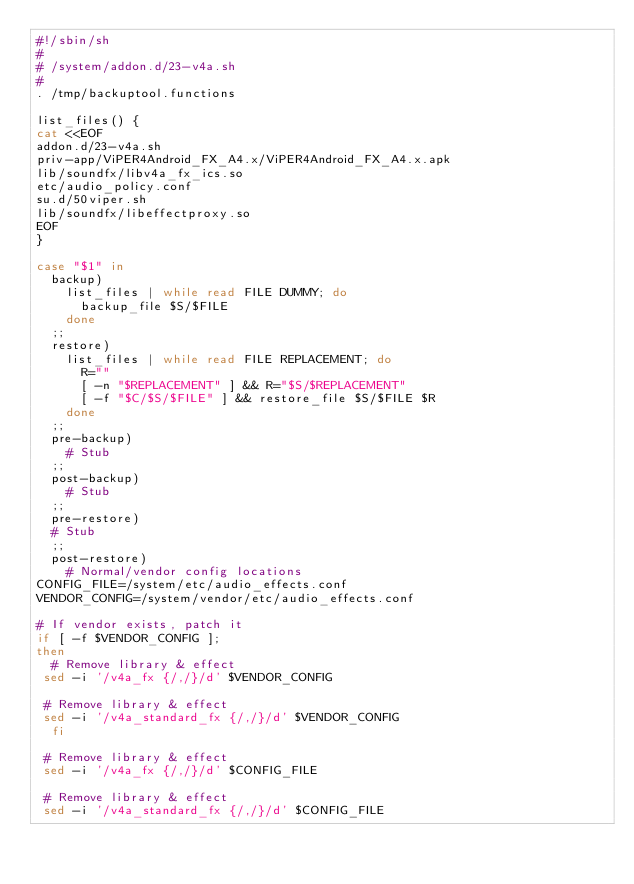<code> <loc_0><loc_0><loc_500><loc_500><_Bash_>#!/sbin/sh
# 
# /system/addon.d/23-v4a.sh
#
. /tmp/backuptool.functions

list_files() {
cat <<EOF
addon.d/23-v4a.sh
priv-app/ViPER4Android_FX_A4.x/ViPER4Android_FX_A4.x.apk
lib/soundfx/libv4a_fx_ics.so
etc/audio_policy.conf
su.d/50viper.sh
lib/soundfx/libeffectproxy.so
EOF
}

case "$1" in
  backup)
    list_files | while read FILE DUMMY; do
      backup_file $S/$FILE
    done
  ;;
  restore)
    list_files | while read FILE REPLACEMENT; do
      R=""
      [ -n "$REPLACEMENT" ] && R="$S/$REPLACEMENT"
      [ -f "$C/$S/$FILE" ] && restore_file $S/$FILE $R
    done
  ;;
  pre-backup)
    # Stub
  ;;
  post-backup)
    # Stub
  ;;
  pre-restore)
	# Stub
  ;;
  post-restore)
    # Normal/vendor config locations
CONFIG_FILE=/system/etc/audio_effects.conf
VENDOR_CONFIG=/system/vendor/etc/audio_effects.conf

# If vendor exists, patch it
if [ -f $VENDOR_CONFIG ];
then
	# Remove library & effect
 sed -i '/v4a_fx {/,/}/d' $VENDOR_CONFIG

 # Remove library & effect
 sed -i '/v4a_standard_fx {/,/}/d' $VENDOR_CONFIG
  fi
 
 # Remove library & effect
 sed -i '/v4a_fx {/,/}/d' $CONFIG_FILE

 # Remove library & effect
 sed -i '/v4a_standard_fx {/,/}/d' $CONFIG_FILE
</code> 